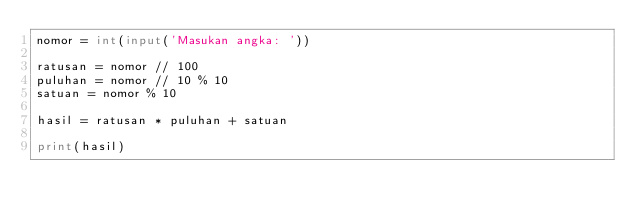Convert code to text. <code><loc_0><loc_0><loc_500><loc_500><_Python_>nomor = int(input('Masukan angka: '))

ratusan = nomor // 100
puluhan = nomor // 10 % 10
satuan = nomor % 10

hasil = ratusan * puluhan + satuan

print(hasil)
</code> 